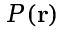Convert formula to latex. <formula><loc_0><loc_0><loc_500><loc_500>P ( r )</formula> 